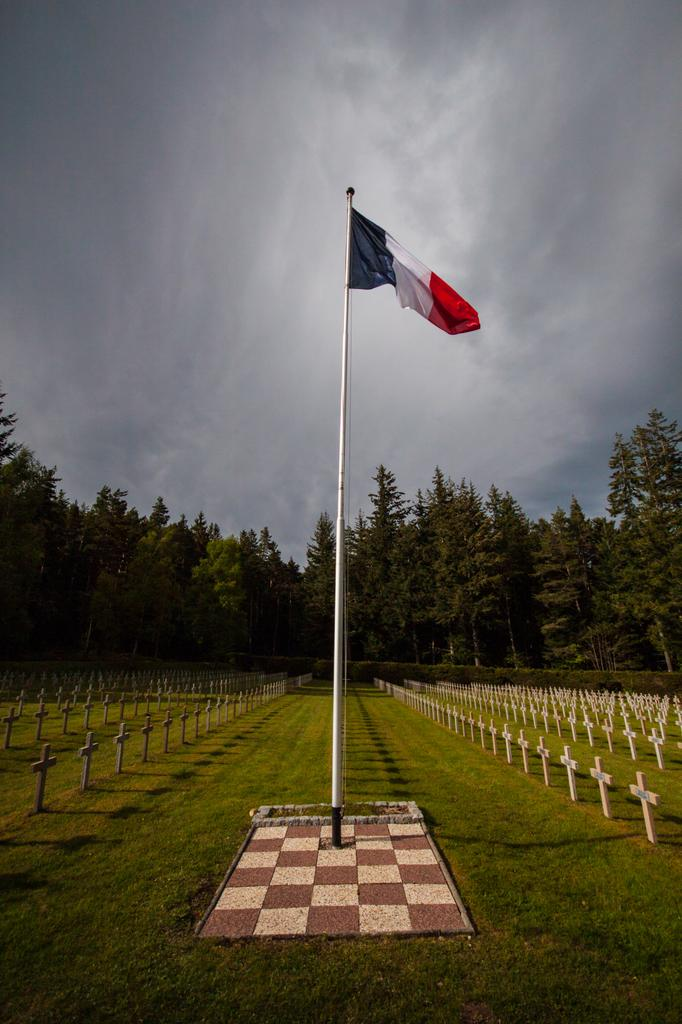What is the main object in the image? There is a flag with a pole in the image. What type of terrain is visible in the image? There is grass visible in the image. What symbols can be seen on the flag? There are cross symbols in the image. What can be seen in the background of the image? There are trees in the background of the image. How would you describe the weather in the image? The sky is cloudy in the image. What type of holiday is being celebrated in the image? There is no indication of a holiday being celebrated in the image. Can you find the receipt for the flag purchase in the image? There is no receipt present in the image. 